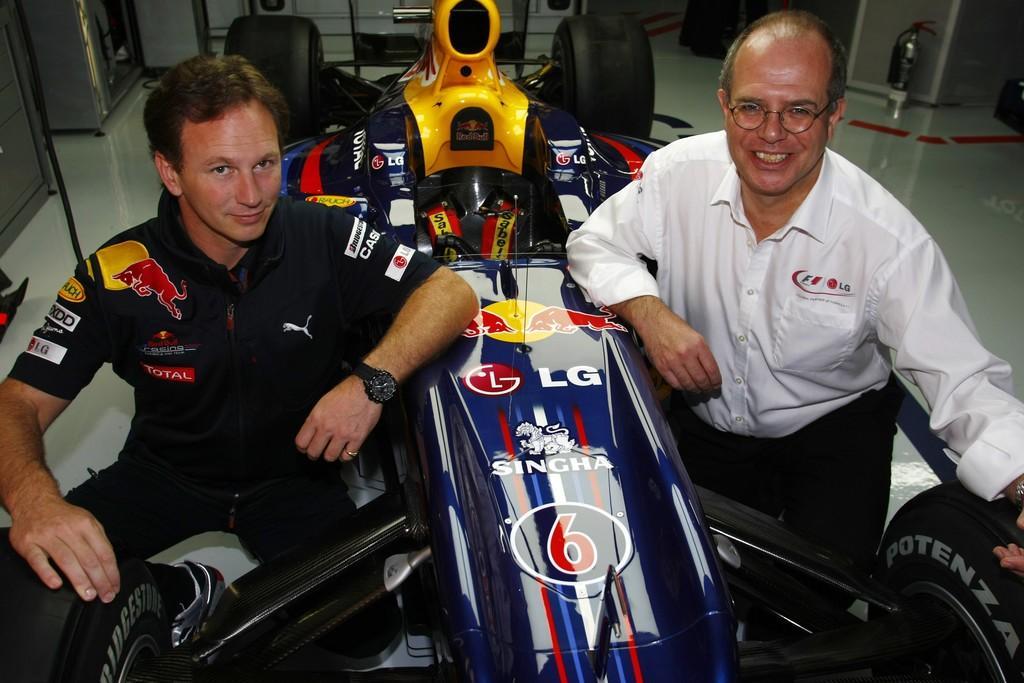Describe this image in one or two sentences. In this image I can see there are two people in the foreground and also an F1 racing car and on the top right hand corner we can see the spray. 